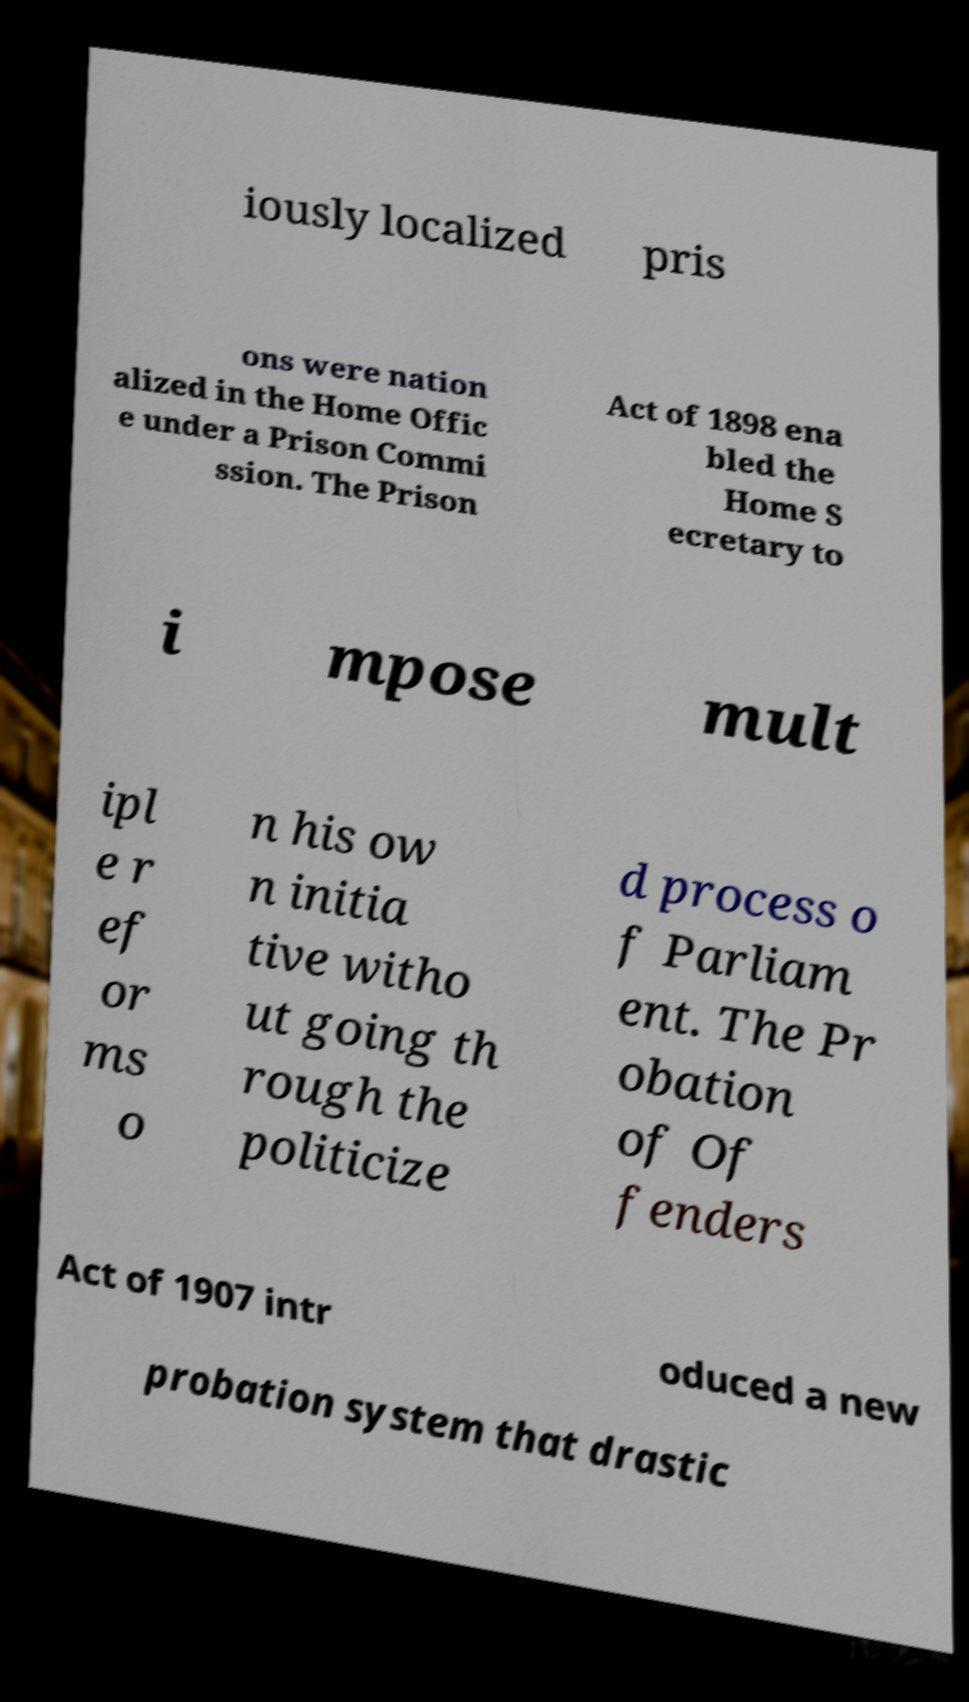Can you read and provide the text displayed in the image?This photo seems to have some interesting text. Can you extract and type it out for me? iously localized pris ons were nation alized in the Home Offic e under a Prison Commi ssion. The Prison Act of 1898 ena bled the Home S ecretary to i mpose mult ipl e r ef or ms o n his ow n initia tive witho ut going th rough the politicize d process o f Parliam ent. The Pr obation of Of fenders Act of 1907 intr oduced a new probation system that drastic 